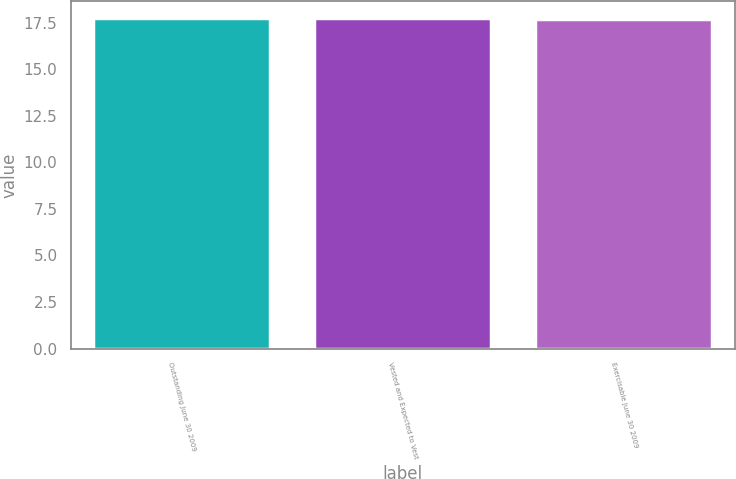Convert chart. <chart><loc_0><loc_0><loc_500><loc_500><bar_chart><fcel>Outstanding June 30 2009<fcel>Vested and Expected to Vest<fcel>Exercisable June 30 2009<nl><fcel>17.75<fcel>17.75<fcel>17.71<nl></chart> 